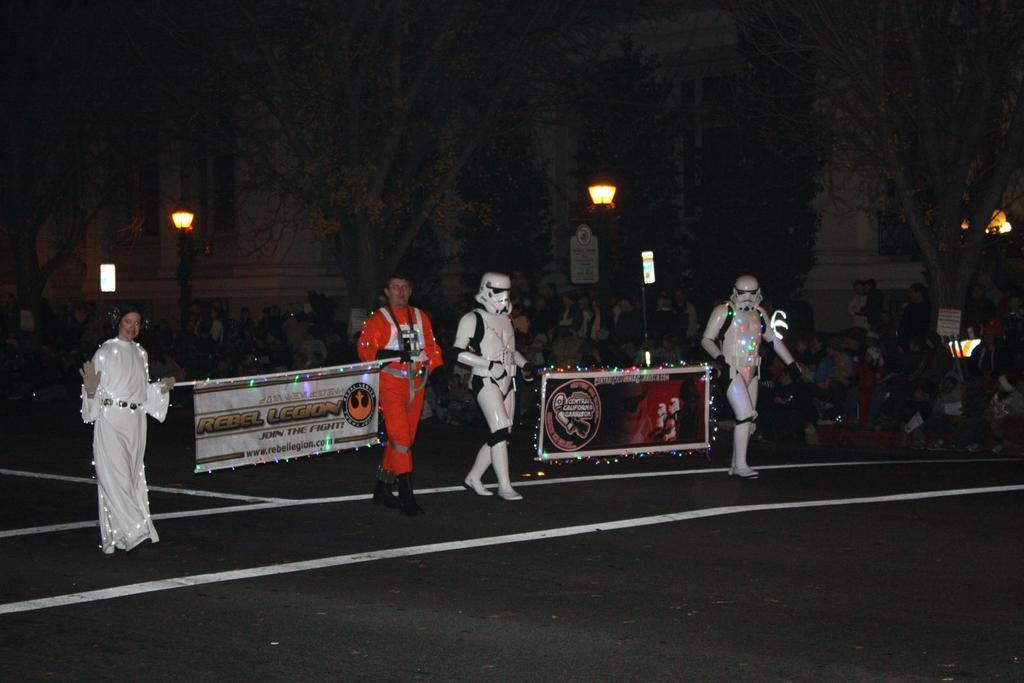What are the persons in the image doing? The persons in the image are walking. What are the persons holding while walking? The persons are holding banners with text and images. Can you describe the background of the image? In the background of the image, there are persons, trees, poles, and buildings. Can you tell me how many firemen are present in the image? There is no fireman present in the image; the persons are holding banners with text and images while walking. What type of joke can be seen on the banners in the image? There is no joke present on the banners in the image; they contain text and images related to the event or cause being promoted. 